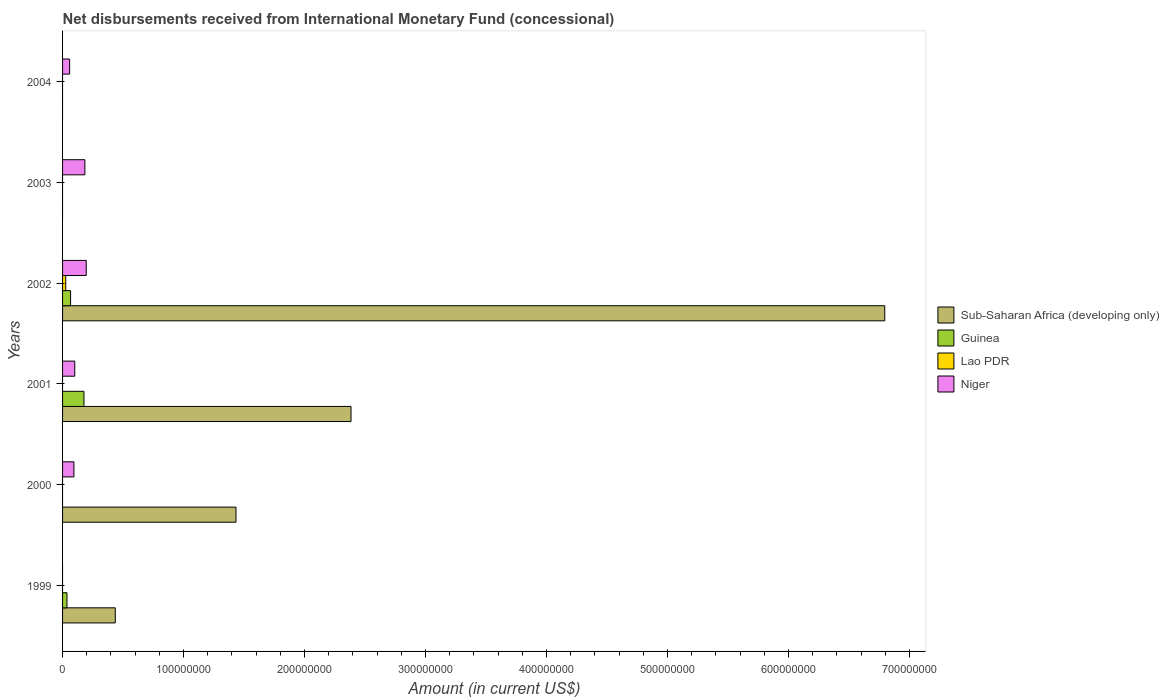How many different coloured bars are there?
Provide a succinct answer. 4. How many bars are there on the 5th tick from the bottom?
Make the answer very short. 1. What is the amount of disbursements received from International Monetary Fund in Sub-Saharan Africa (developing only) in 2002?
Offer a terse response. 6.80e+08. Across all years, what is the maximum amount of disbursements received from International Monetary Fund in Lao PDR?
Provide a short and direct response. 2.62e+06. Across all years, what is the minimum amount of disbursements received from International Monetary Fund in Guinea?
Provide a short and direct response. 0. In which year was the amount of disbursements received from International Monetary Fund in Guinea maximum?
Make the answer very short. 2001. What is the total amount of disbursements received from International Monetary Fund in Guinea in the graph?
Keep it short and to the point. 2.79e+07. What is the difference between the amount of disbursements received from International Monetary Fund in Sub-Saharan Africa (developing only) in 2001 and that in 2002?
Keep it short and to the point. -4.41e+08. What is the difference between the amount of disbursements received from International Monetary Fund in Lao PDR in 2003 and the amount of disbursements received from International Monetary Fund in Guinea in 2002?
Give a very brief answer. -6.62e+06. What is the average amount of disbursements received from International Monetary Fund in Lao PDR per year?
Keep it short and to the point. 4.36e+05. In the year 2002, what is the difference between the amount of disbursements received from International Monetary Fund in Guinea and amount of disbursements received from International Monetary Fund in Lao PDR?
Your answer should be compact. 4.00e+06. In how many years, is the amount of disbursements received from International Monetary Fund in Guinea greater than 640000000 US$?
Make the answer very short. 0. What is the ratio of the amount of disbursements received from International Monetary Fund in Niger in 2000 to that in 2004?
Make the answer very short. 1.61. What is the difference between the highest and the second highest amount of disbursements received from International Monetary Fund in Guinea?
Your answer should be very brief. 1.11e+07. What is the difference between the highest and the lowest amount of disbursements received from International Monetary Fund in Lao PDR?
Give a very brief answer. 2.62e+06. In how many years, is the amount of disbursements received from International Monetary Fund in Sub-Saharan Africa (developing only) greater than the average amount of disbursements received from International Monetary Fund in Sub-Saharan Africa (developing only) taken over all years?
Provide a short and direct response. 2. Is the sum of the amount of disbursements received from International Monetary Fund in Sub-Saharan Africa (developing only) in 1999 and 2001 greater than the maximum amount of disbursements received from International Monetary Fund in Niger across all years?
Offer a terse response. Yes. Is it the case that in every year, the sum of the amount of disbursements received from International Monetary Fund in Lao PDR and amount of disbursements received from International Monetary Fund in Guinea is greater than the sum of amount of disbursements received from International Monetary Fund in Niger and amount of disbursements received from International Monetary Fund in Sub-Saharan Africa (developing only)?
Provide a short and direct response. No. Does the graph contain any zero values?
Provide a succinct answer. Yes. How many legend labels are there?
Offer a terse response. 4. How are the legend labels stacked?
Keep it short and to the point. Vertical. What is the title of the graph?
Your answer should be compact. Net disbursements received from International Monetary Fund (concessional). What is the label or title of the Y-axis?
Keep it short and to the point. Years. What is the Amount (in current US$) of Sub-Saharan Africa (developing only) in 1999?
Offer a terse response. 4.36e+07. What is the Amount (in current US$) in Guinea in 1999?
Make the answer very short. 3.64e+06. What is the Amount (in current US$) in Niger in 1999?
Offer a terse response. 0. What is the Amount (in current US$) of Sub-Saharan Africa (developing only) in 2000?
Provide a succinct answer. 1.43e+08. What is the Amount (in current US$) of Niger in 2000?
Offer a terse response. 9.38e+06. What is the Amount (in current US$) of Sub-Saharan Africa (developing only) in 2001?
Provide a succinct answer. 2.38e+08. What is the Amount (in current US$) of Guinea in 2001?
Give a very brief answer. 1.77e+07. What is the Amount (in current US$) of Lao PDR in 2001?
Offer a very short reply. 0. What is the Amount (in current US$) in Niger in 2001?
Your answer should be very brief. 1.01e+07. What is the Amount (in current US$) in Sub-Saharan Africa (developing only) in 2002?
Ensure brevity in your answer.  6.80e+08. What is the Amount (in current US$) in Guinea in 2002?
Provide a succinct answer. 6.62e+06. What is the Amount (in current US$) in Lao PDR in 2002?
Provide a short and direct response. 2.62e+06. What is the Amount (in current US$) of Niger in 2002?
Your response must be concise. 1.96e+07. What is the Amount (in current US$) in Guinea in 2003?
Make the answer very short. 0. What is the Amount (in current US$) of Lao PDR in 2003?
Provide a succinct answer. 0. What is the Amount (in current US$) in Niger in 2003?
Your response must be concise. 1.84e+07. What is the Amount (in current US$) of Lao PDR in 2004?
Give a very brief answer. 0. What is the Amount (in current US$) of Niger in 2004?
Make the answer very short. 5.84e+06. Across all years, what is the maximum Amount (in current US$) in Sub-Saharan Africa (developing only)?
Keep it short and to the point. 6.80e+08. Across all years, what is the maximum Amount (in current US$) in Guinea?
Provide a succinct answer. 1.77e+07. Across all years, what is the maximum Amount (in current US$) of Lao PDR?
Your response must be concise. 2.62e+06. Across all years, what is the maximum Amount (in current US$) in Niger?
Offer a terse response. 1.96e+07. Across all years, what is the minimum Amount (in current US$) of Guinea?
Provide a short and direct response. 0. Across all years, what is the minimum Amount (in current US$) in Niger?
Give a very brief answer. 0. What is the total Amount (in current US$) in Sub-Saharan Africa (developing only) in the graph?
Provide a succinct answer. 1.10e+09. What is the total Amount (in current US$) in Guinea in the graph?
Make the answer very short. 2.79e+07. What is the total Amount (in current US$) of Lao PDR in the graph?
Your answer should be very brief. 2.62e+06. What is the total Amount (in current US$) of Niger in the graph?
Keep it short and to the point. 6.33e+07. What is the difference between the Amount (in current US$) of Sub-Saharan Africa (developing only) in 1999 and that in 2000?
Your answer should be compact. -9.98e+07. What is the difference between the Amount (in current US$) in Sub-Saharan Africa (developing only) in 1999 and that in 2001?
Your answer should be compact. -1.95e+08. What is the difference between the Amount (in current US$) in Guinea in 1999 and that in 2001?
Provide a succinct answer. -1.40e+07. What is the difference between the Amount (in current US$) of Sub-Saharan Africa (developing only) in 1999 and that in 2002?
Offer a terse response. -6.36e+08. What is the difference between the Amount (in current US$) of Guinea in 1999 and that in 2002?
Your response must be concise. -2.98e+06. What is the difference between the Amount (in current US$) in Sub-Saharan Africa (developing only) in 2000 and that in 2001?
Ensure brevity in your answer.  -9.51e+07. What is the difference between the Amount (in current US$) of Niger in 2000 and that in 2001?
Your response must be concise. -7.07e+05. What is the difference between the Amount (in current US$) of Sub-Saharan Africa (developing only) in 2000 and that in 2002?
Offer a very short reply. -5.36e+08. What is the difference between the Amount (in current US$) of Niger in 2000 and that in 2002?
Give a very brief answer. -1.02e+07. What is the difference between the Amount (in current US$) in Niger in 2000 and that in 2003?
Your answer should be very brief. -9.06e+06. What is the difference between the Amount (in current US$) in Niger in 2000 and that in 2004?
Provide a succinct answer. 3.54e+06. What is the difference between the Amount (in current US$) in Sub-Saharan Africa (developing only) in 2001 and that in 2002?
Your answer should be compact. -4.41e+08. What is the difference between the Amount (in current US$) of Guinea in 2001 and that in 2002?
Provide a succinct answer. 1.11e+07. What is the difference between the Amount (in current US$) in Niger in 2001 and that in 2002?
Give a very brief answer. -9.48e+06. What is the difference between the Amount (in current US$) in Niger in 2001 and that in 2003?
Offer a very short reply. -8.36e+06. What is the difference between the Amount (in current US$) in Niger in 2001 and that in 2004?
Give a very brief answer. 4.25e+06. What is the difference between the Amount (in current US$) of Niger in 2002 and that in 2003?
Offer a terse response. 1.12e+06. What is the difference between the Amount (in current US$) of Niger in 2002 and that in 2004?
Offer a terse response. 1.37e+07. What is the difference between the Amount (in current US$) of Niger in 2003 and that in 2004?
Make the answer very short. 1.26e+07. What is the difference between the Amount (in current US$) of Sub-Saharan Africa (developing only) in 1999 and the Amount (in current US$) of Niger in 2000?
Give a very brief answer. 3.42e+07. What is the difference between the Amount (in current US$) of Guinea in 1999 and the Amount (in current US$) of Niger in 2000?
Your answer should be very brief. -5.74e+06. What is the difference between the Amount (in current US$) in Sub-Saharan Africa (developing only) in 1999 and the Amount (in current US$) in Guinea in 2001?
Give a very brief answer. 2.59e+07. What is the difference between the Amount (in current US$) of Sub-Saharan Africa (developing only) in 1999 and the Amount (in current US$) of Niger in 2001?
Offer a terse response. 3.35e+07. What is the difference between the Amount (in current US$) of Guinea in 1999 and the Amount (in current US$) of Niger in 2001?
Offer a very short reply. -6.45e+06. What is the difference between the Amount (in current US$) of Sub-Saharan Africa (developing only) in 1999 and the Amount (in current US$) of Guinea in 2002?
Keep it short and to the point. 3.70e+07. What is the difference between the Amount (in current US$) of Sub-Saharan Africa (developing only) in 1999 and the Amount (in current US$) of Lao PDR in 2002?
Provide a short and direct response. 4.10e+07. What is the difference between the Amount (in current US$) of Sub-Saharan Africa (developing only) in 1999 and the Amount (in current US$) of Niger in 2002?
Your answer should be compact. 2.40e+07. What is the difference between the Amount (in current US$) in Guinea in 1999 and the Amount (in current US$) in Lao PDR in 2002?
Provide a short and direct response. 1.02e+06. What is the difference between the Amount (in current US$) of Guinea in 1999 and the Amount (in current US$) of Niger in 2002?
Keep it short and to the point. -1.59e+07. What is the difference between the Amount (in current US$) of Sub-Saharan Africa (developing only) in 1999 and the Amount (in current US$) of Niger in 2003?
Your answer should be compact. 2.51e+07. What is the difference between the Amount (in current US$) of Guinea in 1999 and the Amount (in current US$) of Niger in 2003?
Give a very brief answer. -1.48e+07. What is the difference between the Amount (in current US$) of Sub-Saharan Africa (developing only) in 1999 and the Amount (in current US$) of Niger in 2004?
Your response must be concise. 3.77e+07. What is the difference between the Amount (in current US$) of Guinea in 1999 and the Amount (in current US$) of Niger in 2004?
Offer a very short reply. -2.20e+06. What is the difference between the Amount (in current US$) in Sub-Saharan Africa (developing only) in 2000 and the Amount (in current US$) in Guinea in 2001?
Provide a short and direct response. 1.26e+08. What is the difference between the Amount (in current US$) of Sub-Saharan Africa (developing only) in 2000 and the Amount (in current US$) of Niger in 2001?
Offer a very short reply. 1.33e+08. What is the difference between the Amount (in current US$) in Sub-Saharan Africa (developing only) in 2000 and the Amount (in current US$) in Guinea in 2002?
Provide a succinct answer. 1.37e+08. What is the difference between the Amount (in current US$) of Sub-Saharan Africa (developing only) in 2000 and the Amount (in current US$) of Lao PDR in 2002?
Make the answer very short. 1.41e+08. What is the difference between the Amount (in current US$) in Sub-Saharan Africa (developing only) in 2000 and the Amount (in current US$) in Niger in 2002?
Give a very brief answer. 1.24e+08. What is the difference between the Amount (in current US$) of Sub-Saharan Africa (developing only) in 2000 and the Amount (in current US$) of Niger in 2003?
Your response must be concise. 1.25e+08. What is the difference between the Amount (in current US$) in Sub-Saharan Africa (developing only) in 2000 and the Amount (in current US$) in Niger in 2004?
Your response must be concise. 1.38e+08. What is the difference between the Amount (in current US$) of Sub-Saharan Africa (developing only) in 2001 and the Amount (in current US$) of Guinea in 2002?
Give a very brief answer. 2.32e+08. What is the difference between the Amount (in current US$) in Sub-Saharan Africa (developing only) in 2001 and the Amount (in current US$) in Lao PDR in 2002?
Offer a very short reply. 2.36e+08. What is the difference between the Amount (in current US$) in Sub-Saharan Africa (developing only) in 2001 and the Amount (in current US$) in Niger in 2002?
Ensure brevity in your answer.  2.19e+08. What is the difference between the Amount (in current US$) of Guinea in 2001 and the Amount (in current US$) of Lao PDR in 2002?
Offer a very short reply. 1.51e+07. What is the difference between the Amount (in current US$) in Guinea in 2001 and the Amount (in current US$) in Niger in 2002?
Your answer should be compact. -1.90e+06. What is the difference between the Amount (in current US$) of Sub-Saharan Africa (developing only) in 2001 and the Amount (in current US$) of Niger in 2003?
Provide a succinct answer. 2.20e+08. What is the difference between the Amount (in current US$) of Guinea in 2001 and the Amount (in current US$) of Niger in 2003?
Your answer should be very brief. -7.70e+05. What is the difference between the Amount (in current US$) in Sub-Saharan Africa (developing only) in 2001 and the Amount (in current US$) in Niger in 2004?
Your answer should be very brief. 2.33e+08. What is the difference between the Amount (in current US$) of Guinea in 2001 and the Amount (in current US$) of Niger in 2004?
Your response must be concise. 1.18e+07. What is the difference between the Amount (in current US$) of Sub-Saharan Africa (developing only) in 2002 and the Amount (in current US$) of Niger in 2003?
Provide a short and direct response. 6.61e+08. What is the difference between the Amount (in current US$) in Guinea in 2002 and the Amount (in current US$) in Niger in 2003?
Your response must be concise. -1.18e+07. What is the difference between the Amount (in current US$) in Lao PDR in 2002 and the Amount (in current US$) in Niger in 2003?
Offer a very short reply. -1.58e+07. What is the difference between the Amount (in current US$) in Sub-Saharan Africa (developing only) in 2002 and the Amount (in current US$) in Niger in 2004?
Your response must be concise. 6.74e+08. What is the difference between the Amount (in current US$) of Guinea in 2002 and the Amount (in current US$) of Niger in 2004?
Ensure brevity in your answer.  7.77e+05. What is the difference between the Amount (in current US$) of Lao PDR in 2002 and the Amount (in current US$) of Niger in 2004?
Offer a very short reply. -3.22e+06. What is the average Amount (in current US$) of Sub-Saharan Africa (developing only) per year?
Offer a terse response. 1.84e+08. What is the average Amount (in current US$) of Guinea per year?
Your response must be concise. 4.65e+06. What is the average Amount (in current US$) of Lao PDR per year?
Your answer should be compact. 4.36e+05. What is the average Amount (in current US$) of Niger per year?
Provide a succinct answer. 1.06e+07. In the year 1999, what is the difference between the Amount (in current US$) of Sub-Saharan Africa (developing only) and Amount (in current US$) of Guinea?
Offer a terse response. 3.99e+07. In the year 2000, what is the difference between the Amount (in current US$) in Sub-Saharan Africa (developing only) and Amount (in current US$) in Niger?
Provide a short and direct response. 1.34e+08. In the year 2001, what is the difference between the Amount (in current US$) in Sub-Saharan Africa (developing only) and Amount (in current US$) in Guinea?
Make the answer very short. 2.21e+08. In the year 2001, what is the difference between the Amount (in current US$) in Sub-Saharan Africa (developing only) and Amount (in current US$) in Niger?
Provide a short and direct response. 2.28e+08. In the year 2001, what is the difference between the Amount (in current US$) in Guinea and Amount (in current US$) in Niger?
Your answer should be very brief. 7.58e+06. In the year 2002, what is the difference between the Amount (in current US$) of Sub-Saharan Africa (developing only) and Amount (in current US$) of Guinea?
Your answer should be compact. 6.73e+08. In the year 2002, what is the difference between the Amount (in current US$) of Sub-Saharan Africa (developing only) and Amount (in current US$) of Lao PDR?
Your response must be concise. 6.77e+08. In the year 2002, what is the difference between the Amount (in current US$) in Sub-Saharan Africa (developing only) and Amount (in current US$) in Niger?
Offer a very short reply. 6.60e+08. In the year 2002, what is the difference between the Amount (in current US$) in Guinea and Amount (in current US$) in Lao PDR?
Your response must be concise. 4.00e+06. In the year 2002, what is the difference between the Amount (in current US$) of Guinea and Amount (in current US$) of Niger?
Provide a short and direct response. -1.30e+07. In the year 2002, what is the difference between the Amount (in current US$) of Lao PDR and Amount (in current US$) of Niger?
Keep it short and to the point. -1.70e+07. What is the ratio of the Amount (in current US$) in Sub-Saharan Africa (developing only) in 1999 to that in 2000?
Ensure brevity in your answer.  0.3. What is the ratio of the Amount (in current US$) of Sub-Saharan Africa (developing only) in 1999 to that in 2001?
Your answer should be very brief. 0.18. What is the ratio of the Amount (in current US$) of Guinea in 1999 to that in 2001?
Ensure brevity in your answer.  0.21. What is the ratio of the Amount (in current US$) in Sub-Saharan Africa (developing only) in 1999 to that in 2002?
Offer a very short reply. 0.06. What is the ratio of the Amount (in current US$) of Guinea in 1999 to that in 2002?
Make the answer very short. 0.55. What is the ratio of the Amount (in current US$) in Sub-Saharan Africa (developing only) in 2000 to that in 2001?
Your answer should be compact. 0.6. What is the ratio of the Amount (in current US$) of Niger in 2000 to that in 2001?
Give a very brief answer. 0.93. What is the ratio of the Amount (in current US$) in Sub-Saharan Africa (developing only) in 2000 to that in 2002?
Make the answer very short. 0.21. What is the ratio of the Amount (in current US$) in Niger in 2000 to that in 2002?
Provide a succinct answer. 0.48. What is the ratio of the Amount (in current US$) of Niger in 2000 to that in 2003?
Your response must be concise. 0.51. What is the ratio of the Amount (in current US$) of Niger in 2000 to that in 2004?
Give a very brief answer. 1.61. What is the ratio of the Amount (in current US$) in Sub-Saharan Africa (developing only) in 2001 to that in 2002?
Keep it short and to the point. 0.35. What is the ratio of the Amount (in current US$) in Guinea in 2001 to that in 2002?
Offer a terse response. 2.67. What is the ratio of the Amount (in current US$) in Niger in 2001 to that in 2002?
Your answer should be compact. 0.52. What is the ratio of the Amount (in current US$) in Niger in 2001 to that in 2003?
Offer a very short reply. 0.55. What is the ratio of the Amount (in current US$) of Niger in 2001 to that in 2004?
Provide a short and direct response. 1.73. What is the ratio of the Amount (in current US$) of Niger in 2002 to that in 2003?
Your answer should be very brief. 1.06. What is the ratio of the Amount (in current US$) in Niger in 2002 to that in 2004?
Offer a terse response. 3.35. What is the ratio of the Amount (in current US$) of Niger in 2003 to that in 2004?
Offer a very short reply. 3.16. What is the difference between the highest and the second highest Amount (in current US$) of Sub-Saharan Africa (developing only)?
Make the answer very short. 4.41e+08. What is the difference between the highest and the second highest Amount (in current US$) in Guinea?
Your answer should be very brief. 1.11e+07. What is the difference between the highest and the second highest Amount (in current US$) of Niger?
Your answer should be very brief. 1.12e+06. What is the difference between the highest and the lowest Amount (in current US$) in Sub-Saharan Africa (developing only)?
Offer a very short reply. 6.80e+08. What is the difference between the highest and the lowest Amount (in current US$) of Guinea?
Offer a very short reply. 1.77e+07. What is the difference between the highest and the lowest Amount (in current US$) of Lao PDR?
Your answer should be very brief. 2.62e+06. What is the difference between the highest and the lowest Amount (in current US$) in Niger?
Offer a very short reply. 1.96e+07. 